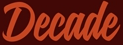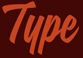Identify the words shown in these images in order, separated by a semicolon. Decade; Type 